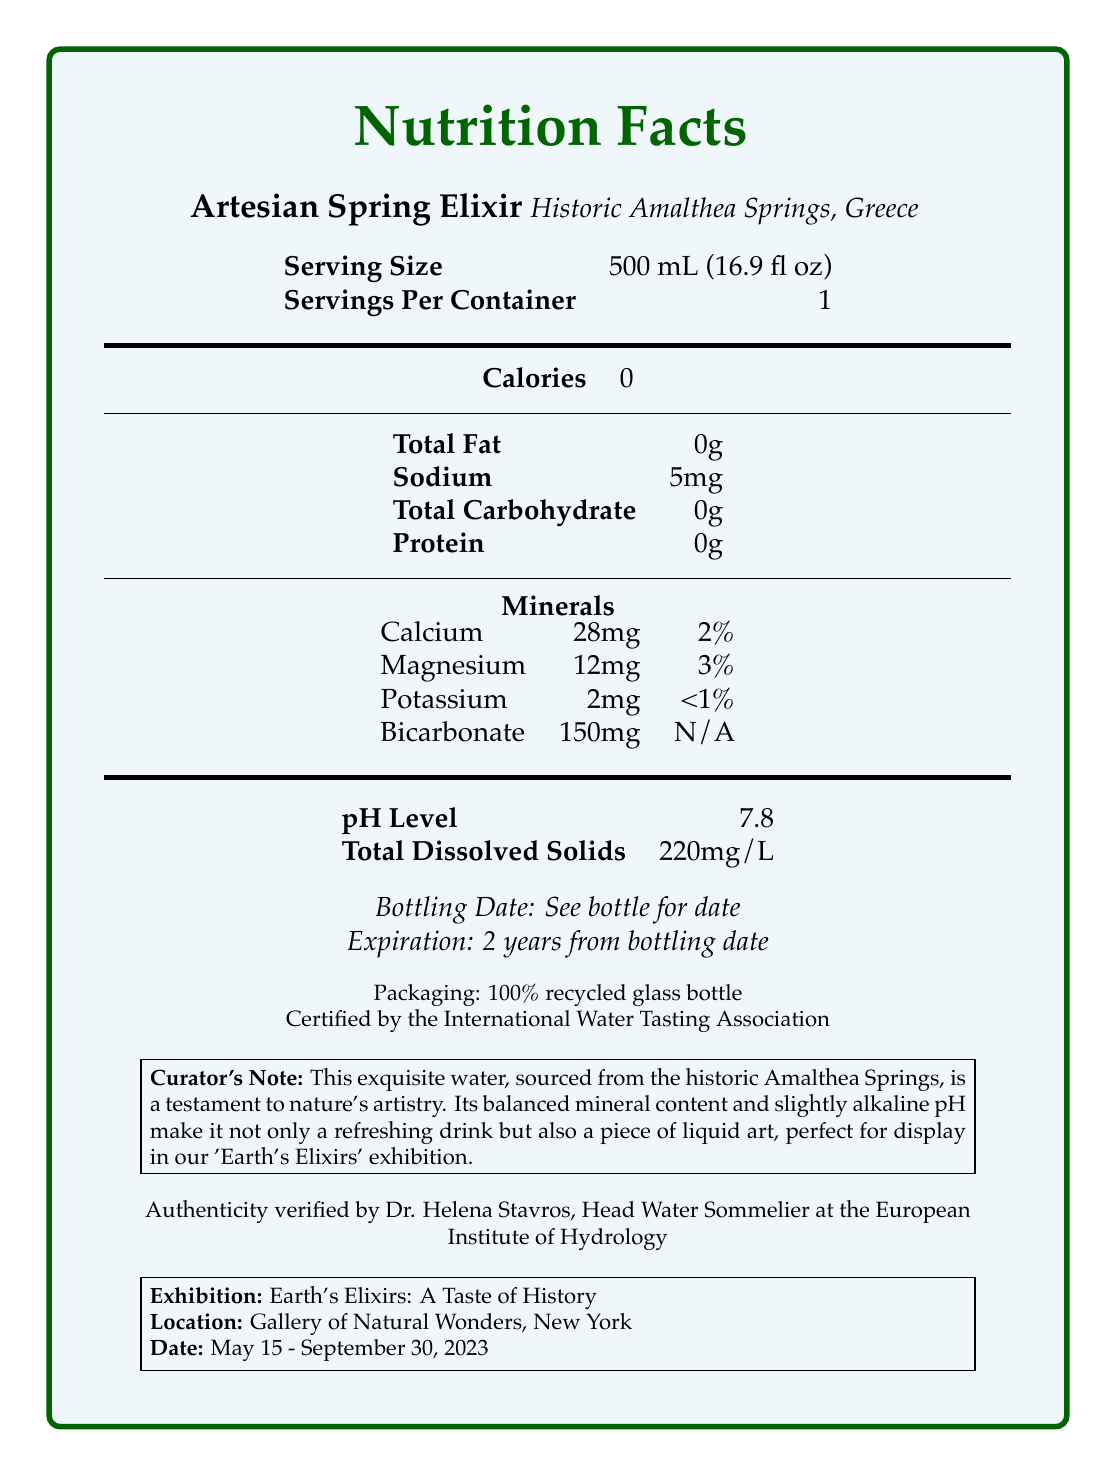what is the serving size? The serving size is explicitly stated under the product name and source.
Answer: 500 mL (16.9 fl oz) how much sodium is in a single serving? The sodium content is listed in the nutrient breakdown section.
Answer: 5mg how long is the water expected to last after bottling? The expiration date information is given as "2 years from bottling date".
Answer: 2 years from bottling date what is the pH level of the Artesian Spring Elixir? The pH level is stated in the section listing pH and total dissolved solids.
Answer: 7.8 what minerals are present in the Artesian Spring Elixir? The minerals and their amounts are listed in the nutrition information.
Answer: Calcium, Magnesium, Potassium, Bicarbonate how many calories are in a serving of the Artesian Spring Elixir? A. 0 B. 5 C. 10 D. 15 The calories are clearly listed as 0 under the calories section.
Answer: A. 0 which of the following minerals is present in the highest amount per serving? I. Calcium II. Magnesium III. Potassium IV. Bicarbonate Bicarbonate is present at 150mg, which is higher than the amounts of Calcium (28mg), Magnesium (12mg), and Potassium (2mg).
Answer: IV. Bicarbonate is the bottling date specified in the document? The document instructs to "See bottle for date" for the bottling date.
Answer: No is this water certified? The document states that it is "Certified by the International Water Tasting Association."
Answer: Yes summarize the main idea of this document. The document contains detailed nutritional information of a premium bottled water along with endorsements and exhibition details, conveying both its health benefits and its cultural significance.
Answer: This document is a Nutrition Facts Label for 'Artesian Spring Elixir,' a premium bottled water sourced from Historic Amalthea Springs, Greece. It provides information about serving size, nutritional content, mineral composition, pH level, and certification, and includes curator and appraiser details, as well as exhibition information. who verified the authenticity of the water? The authenticity verification is mentioned at the end of the document.
Answer: Dr. Helena Stavros, Head Water Sommelier at the European Institute of Hydrology where is the Artesian Spring Elixir sourced from? The source is stated below the product name.
Answer: Historic Amalthea Springs, Greece what percentage daily value of Magnesium does a serving provide? The document lists 12mg of Magnesium which accounts for 3% of the daily value.
Answer: 3% what is the total dissolved solids content in the water? The document lists this value under the pH level and total dissolved solids section.
Answer: 220mg/L is the packaging environmentally friendly? The document states that the packaging is made from "100% recycled glass bottle."
Answer: Yes how many servings are in each container? The servings per container are listed as 1 directly below the serving size.
Answer: 1 what is Dr. Helena Stavros’ role? This information is given in the authentication section.
Answer: Head Water Sommelier at the European Institute of Hydrology 